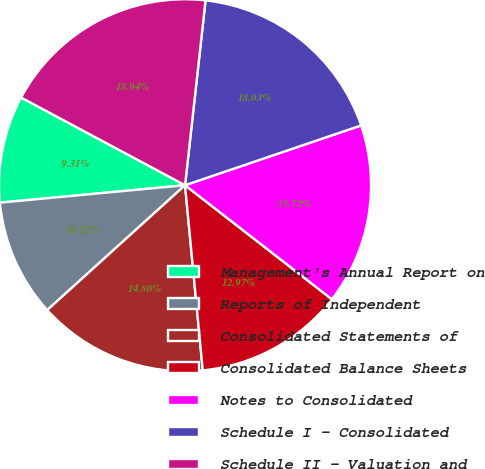Convert chart to OTSL. <chart><loc_0><loc_0><loc_500><loc_500><pie_chart><fcel>Management's Annual Report on<fcel>Reports of Independent<fcel>Consolidated Statements of<fcel>Consolidated Balance Sheets<fcel>Notes to Consolidated<fcel>Schedule I - Consolidated<fcel>Schedule II - Valuation and<nl><fcel>9.31%<fcel>10.22%<fcel>14.8%<fcel>12.97%<fcel>15.72%<fcel>18.03%<fcel>18.94%<nl></chart> 